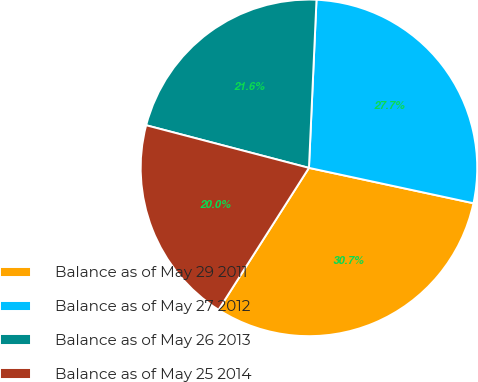<chart> <loc_0><loc_0><loc_500><loc_500><pie_chart><fcel>Balance as of May 29 2011<fcel>Balance as of May 27 2012<fcel>Balance as of May 26 2013<fcel>Balance as of May 25 2014<nl><fcel>30.66%<fcel>27.66%<fcel>21.64%<fcel>20.05%<nl></chart> 